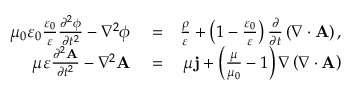<formula> <loc_0><loc_0><loc_500><loc_500>\begin{array} { r l r } { \mu _ { 0 } \varepsilon _ { 0 } \frac { \varepsilon _ { 0 } } { \varepsilon } \frac { \partial ^ { 2 } \phi } { \partial t ^ { 2 } } - \nabla ^ { 2 } \phi } & = } & { \frac { \rho } { \varepsilon } + \left ( 1 - \frac { \varepsilon _ { 0 } } { \varepsilon } \right ) \frac { \partial } { \partial t } \left ( \nabla \cdot A \right ) , } \\ { \mu \varepsilon \frac { \partial ^ { 2 } A } { \partial t ^ { 2 } } - \nabla ^ { 2 } A } & = } & { \mu j + \left ( \frac { \mu } { \mu _ { 0 } } - 1 \right ) \nabla \left ( \nabla \cdot A \right ) } \end{array}</formula> 